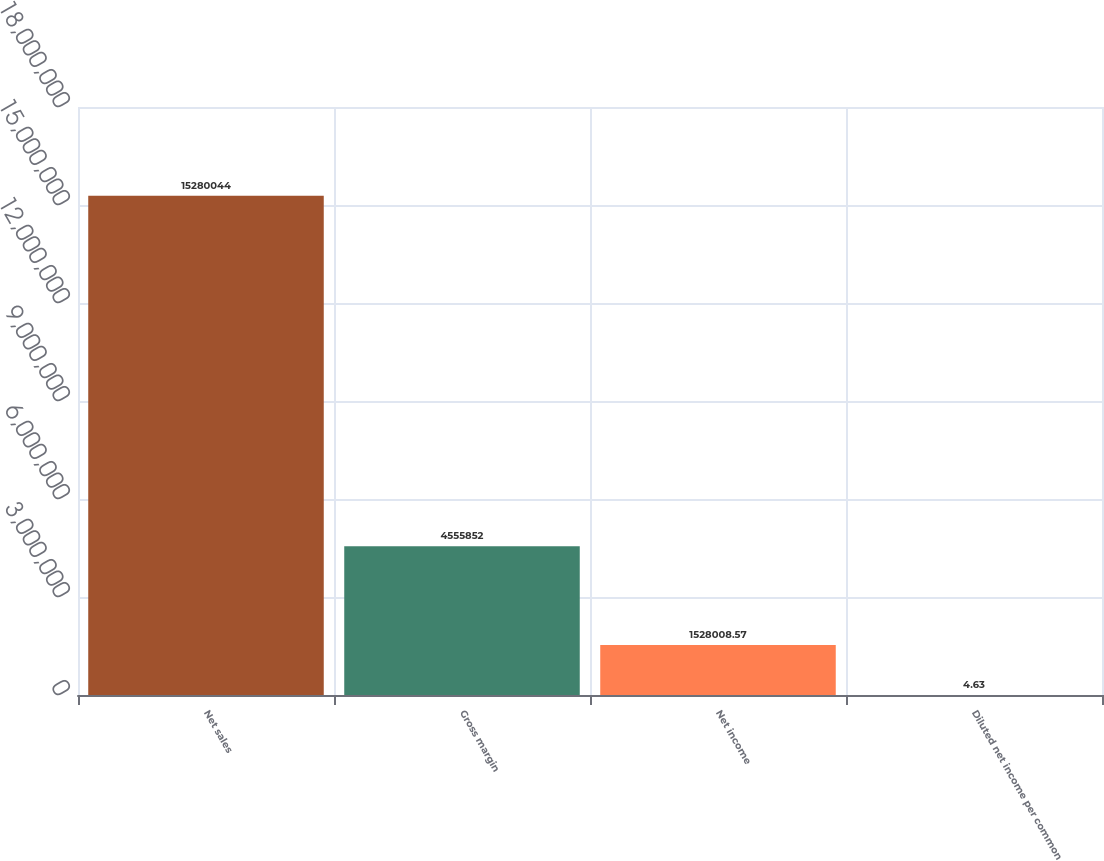<chart> <loc_0><loc_0><loc_500><loc_500><bar_chart><fcel>Net sales<fcel>Gross margin<fcel>Net income<fcel>Diluted net income per common<nl><fcel>1.528e+07<fcel>4.55585e+06<fcel>1.52801e+06<fcel>4.63<nl></chart> 